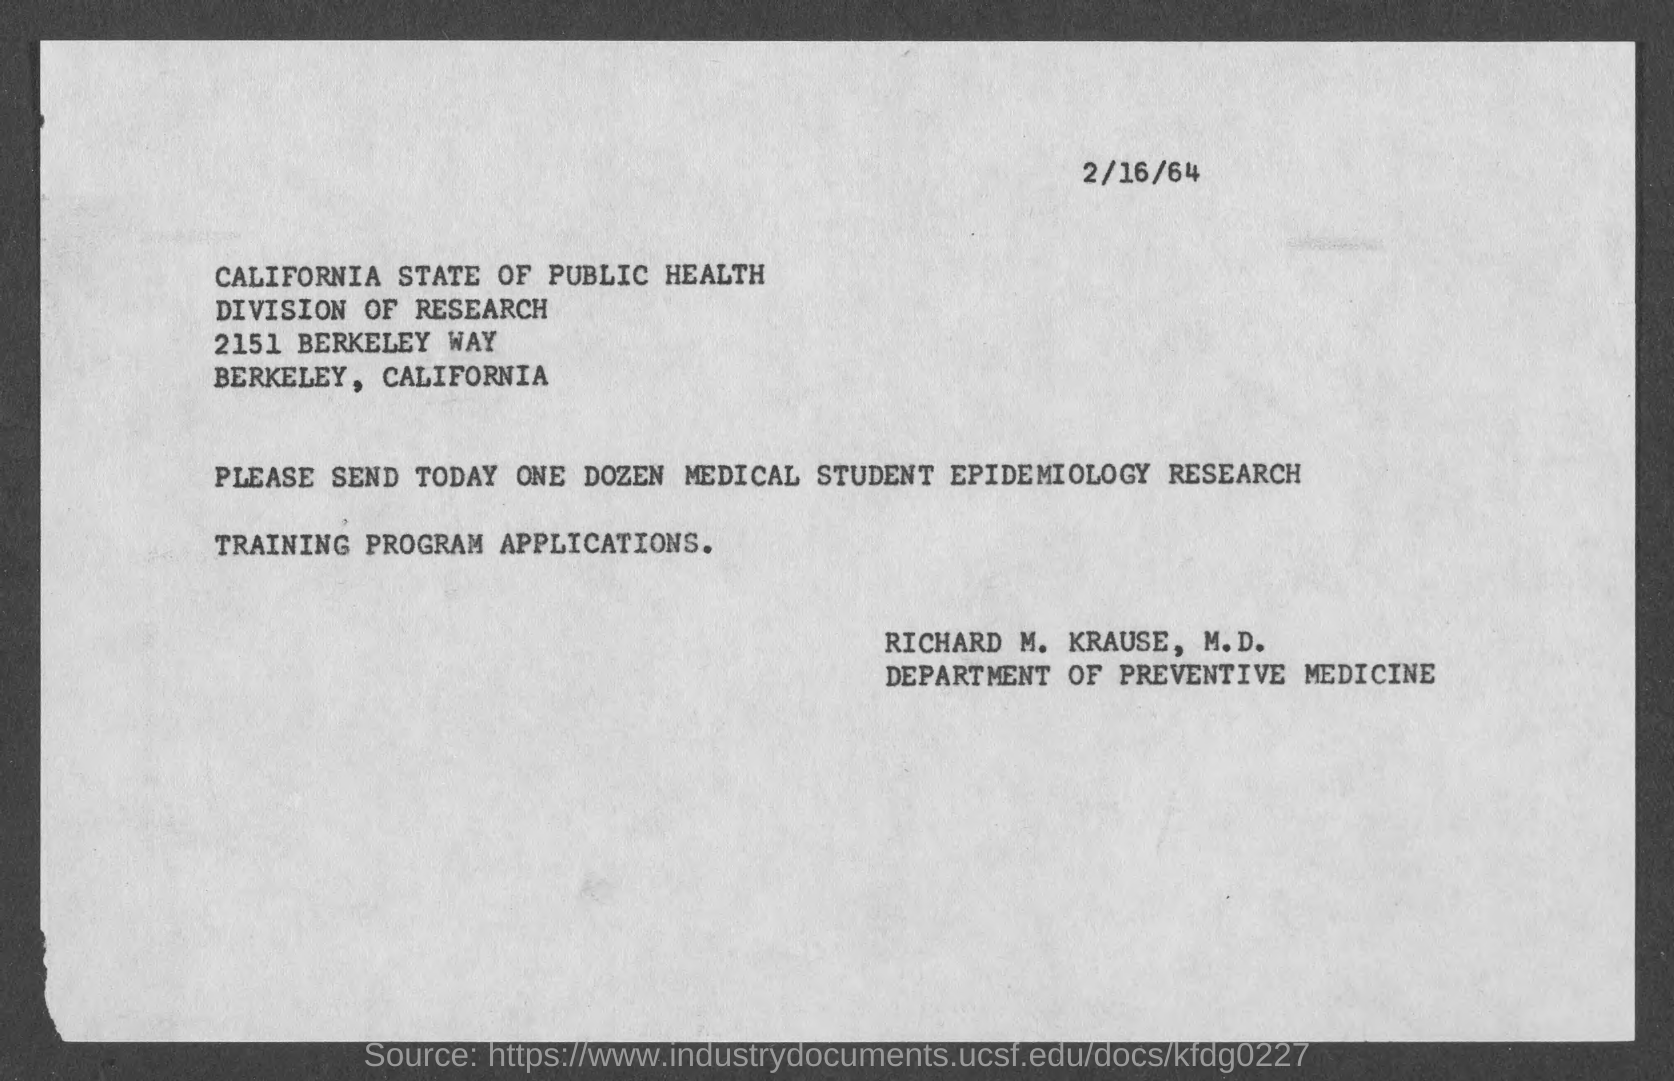What is the date on the document?
Offer a terse response. 2/16/64. How many Medical student epidemiology research Training program applications are to be sent?
Provide a succinct answer. ONE DOZEN. 